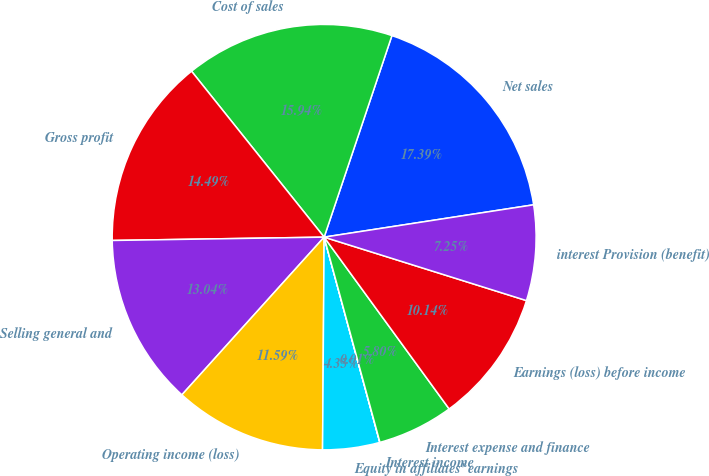Convert chart to OTSL. <chart><loc_0><loc_0><loc_500><loc_500><pie_chart><fcel>Net sales<fcel>Cost of sales<fcel>Gross profit<fcel>Selling general and<fcel>Operating income (loss)<fcel>Equity in affiliates' earnings<fcel>Interest income<fcel>Interest expense and finance<fcel>Earnings (loss) before income<fcel>interest Provision (benefit)<nl><fcel>17.39%<fcel>15.94%<fcel>14.49%<fcel>13.04%<fcel>11.59%<fcel>4.35%<fcel>0.01%<fcel>5.8%<fcel>10.14%<fcel>7.25%<nl></chart> 